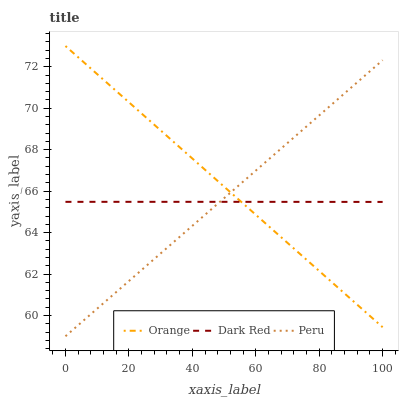Does Dark Red have the minimum area under the curve?
Answer yes or no. Yes. Does Orange have the maximum area under the curve?
Answer yes or no. Yes. Does Peru have the minimum area under the curve?
Answer yes or no. No. Does Peru have the maximum area under the curve?
Answer yes or no. No. Is Orange the smoothest?
Answer yes or no. Yes. Is Dark Red the roughest?
Answer yes or no. Yes. Is Peru the smoothest?
Answer yes or no. No. Is Peru the roughest?
Answer yes or no. No. Does Peru have the lowest value?
Answer yes or no. Yes. Does Dark Red have the lowest value?
Answer yes or no. No. Does Orange have the highest value?
Answer yes or no. Yes. Does Peru have the highest value?
Answer yes or no. No. Does Peru intersect Dark Red?
Answer yes or no. Yes. Is Peru less than Dark Red?
Answer yes or no. No. Is Peru greater than Dark Red?
Answer yes or no. No. 